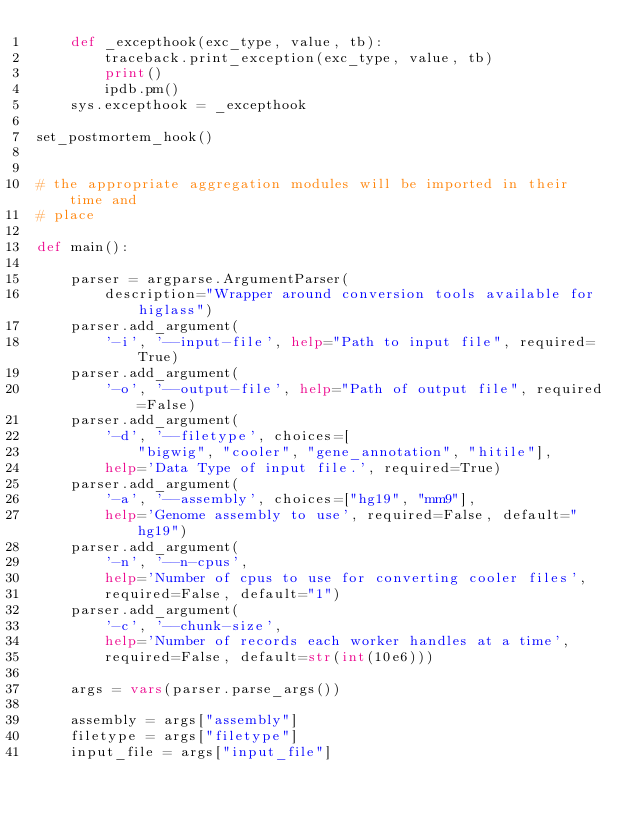<code> <loc_0><loc_0><loc_500><loc_500><_Python_>    def _excepthook(exc_type, value, tb):
        traceback.print_exception(exc_type, value, tb)
        print()
        ipdb.pm()
    sys.excepthook = _excepthook

set_postmortem_hook()


# the appropriate aggregation modules will be imported in their time and
# place

def main():

    parser = argparse.ArgumentParser(
        description="Wrapper around conversion tools available for higlass")
    parser.add_argument(
        '-i', '--input-file', help="Path to input file", required=True)
    parser.add_argument(
        '-o', '--output-file', help="Path of output file", required=False)
    parser.add_argument(
        '-d', '--filetype', choices=[
            "bigwig", "cooler", "gene_annotation", "hitile"],
        help='Data Type of input file.', required=True)
    parser.add_argument(
        '-a', '--assembly', choices=["hg19", "mm9"],
        help='Genome assembly to use', required=False, default="hg19")
    parser.add_argument(
        '-n', '--n-cpus',
        help='Number of cpus to use for converting cooler files',
        required=False, default="1")
    parser.add_argument(
        '-c', '--chunk-size',
        help='Number of records each worker handles at a time',
        required=False, default=str(int(10e6)))

    args = vars(parser.parse_args())

    assembly = args["assembly"]
    filetype = args["filetype"]
    input_file = args["input_file"]</code> 